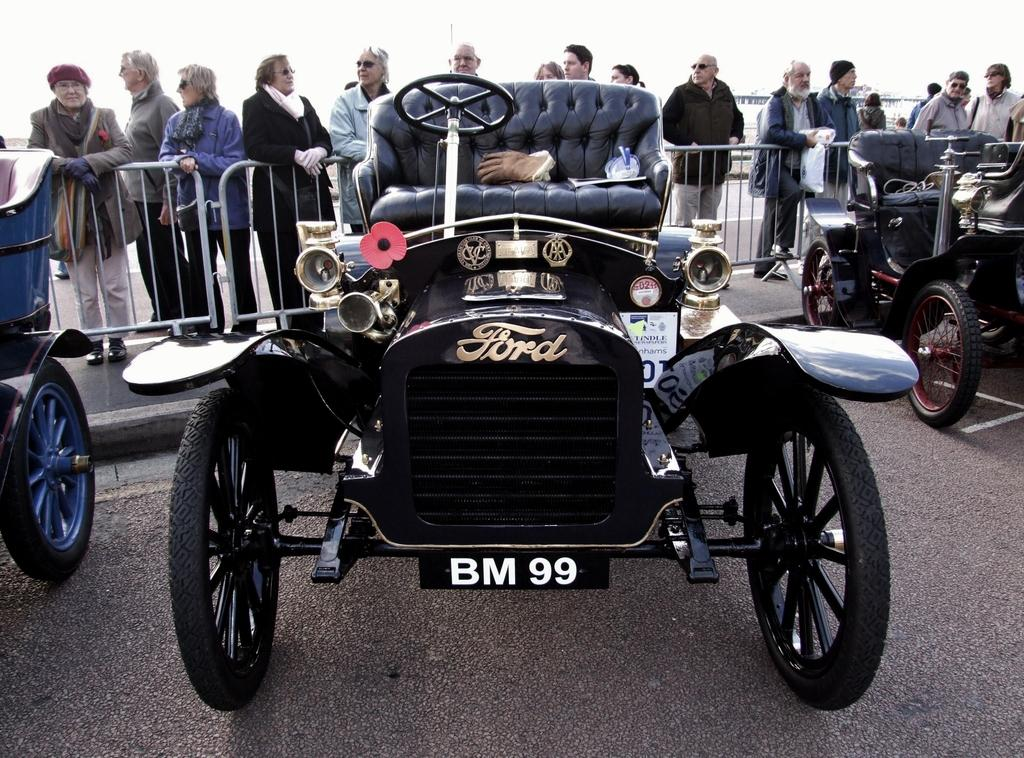What can be seen on the road in the image? There are vehicles parked on the road in the image. What else is visible in the background of the image? A group of people are standing near barricades in the background. What type of chain can be seen connecting the vehicles in the image? There is no chain connecting the vehicles in the image; they are parked separately. 